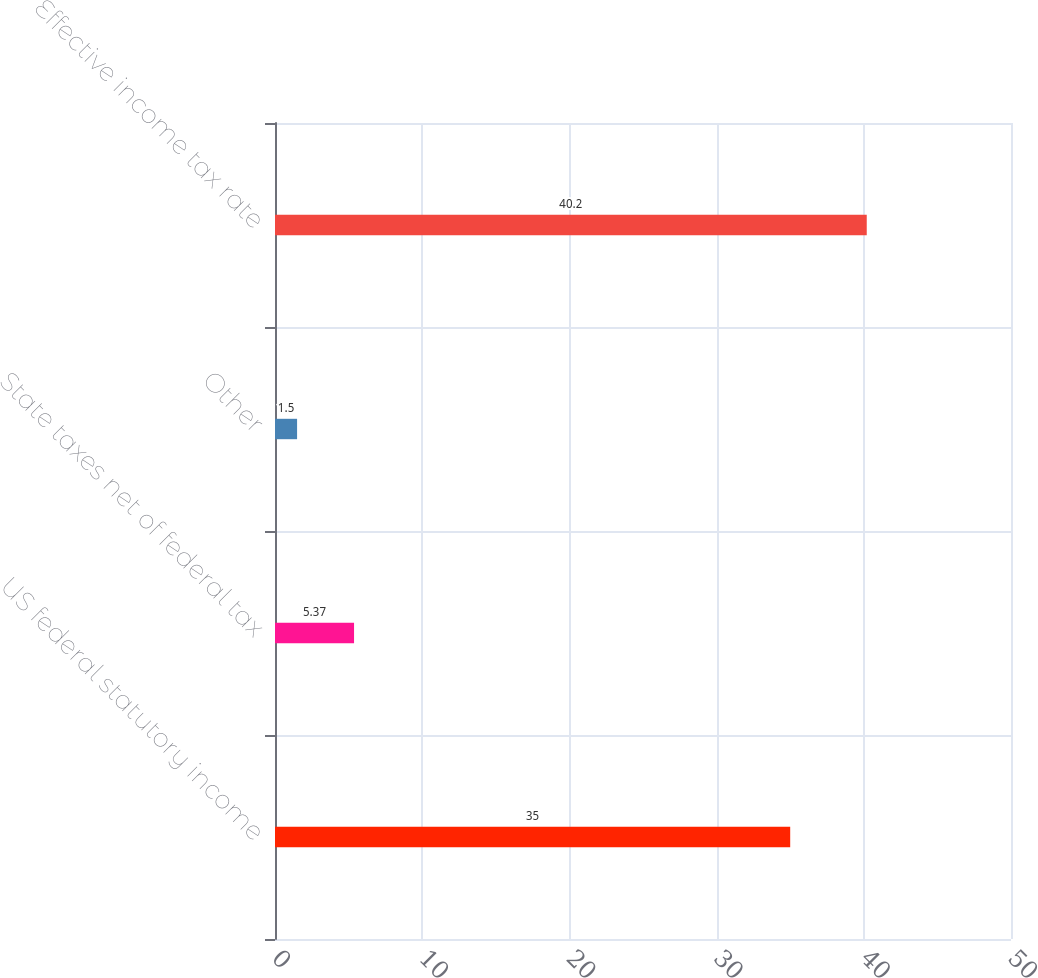<chart> <loc_0><loc_0><loc_500><loc_500><bar_chart><fcel>US federal statutory income<fcel>State taxes net of federal tax<fcel>Other<fcel>Effective income tax rate<nl><fcel>35<fcel>5.37<fcel>1.5<fcel>40.2<nl></chart> 